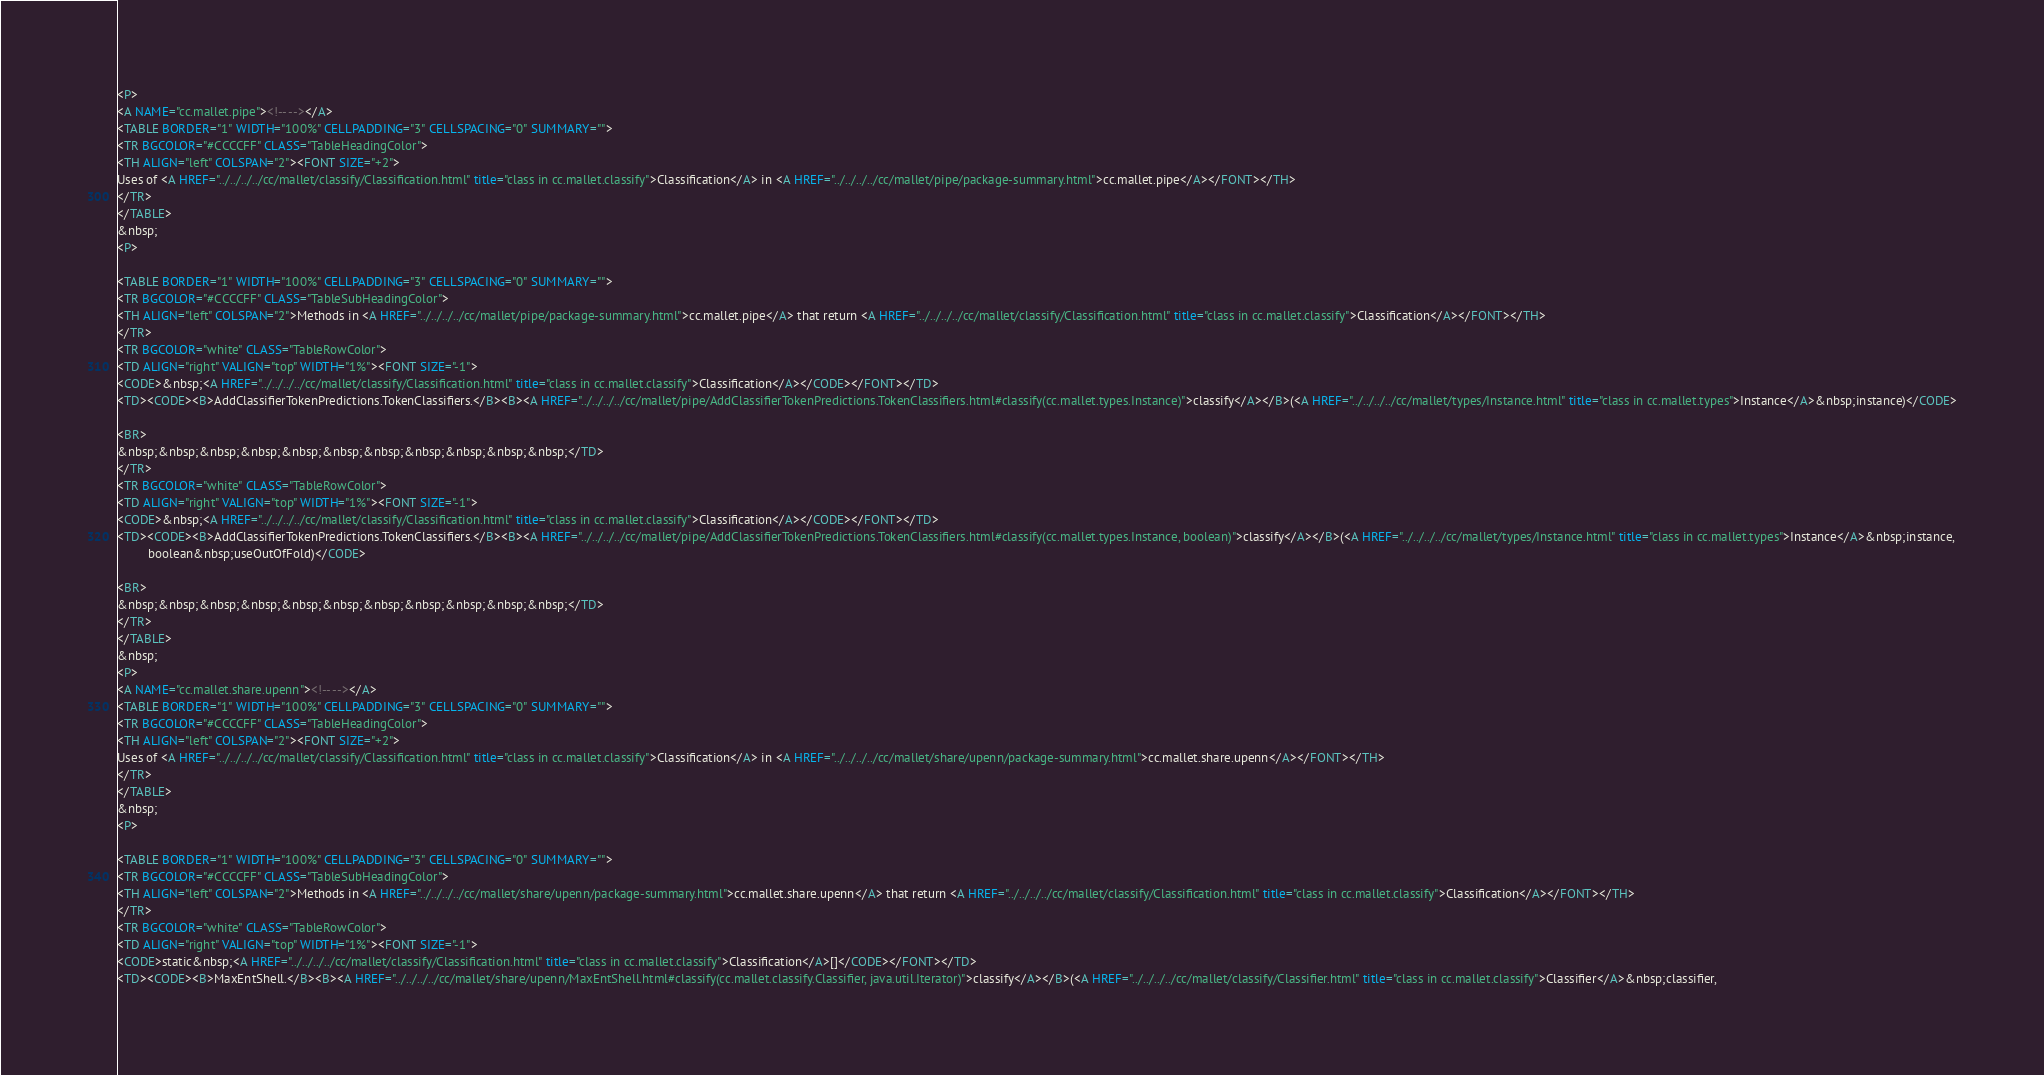<code> <loc_0><loc_0><loc_500><loc_500><_HTML_><P>
<A NAME="cc.mallet.pipe"><!-- --></A>
<TABLE BORDER="1" WIDTH="100%" CELLPADDING="3" CELLSPACING="0" SUMMARY="">
<TR BGCOLOR="#CCCCFF" CLASS="TableHeadingColor">
<TH ALIGN="left" COLSPAN="2"><FONT SIZE="+2">
Uses of <A HREF="../../../../cc/mallet/classify/Classification.html" title="class in cc.mallet.classify">Classification</A> in <A HREF="../../../../cc/mallet/pipe/package-summary.html">cc.mallet.pipe</A></FONT></TH>
</TR>
</TABLE>
&nbsp;
<P>

<TABLE BORDER="1" WIDTH="100%" CELLPADDING="3" CELLSPACING="0" SUMMARY="">
<TR BGCOLOR="#CCCCFF" CLASS="TableSubHeadingColor">
<TH ALIGN="left" COLSPAN="2">Methods in <A HREF="../../../../cc/mallet/pipe/package-summary.html">cc.mallet.pipe</A> that return <A HREF="../../../../cc/mallet/classify/Classification.html" title="class in cc.mallet.classify">Classification</A></FONT></TH>
</TR>
<TR BGCOLOR="white" CLASS="TableRowColor">
<TD ALIGN="right" VALIGN="top" WIDTH="1%"><FONT SIZE="-1">
<CODE>&nbsp;<A HREF="../../../../cc/mallet/classify/Classification.html" title="class in cc.mallet.classify">Classification</A></CODE></FONT></TD>
<TD><CODE><B>AddClassifierTokenPredictions.TokenClassifiers.</B><B><A HREF="../../../../cc/mallet/pipe/AddClassifierTokenPredictions.TokenClassifiers.html#classify(cc.mallet.types.Instance)">classify</A></B>(<A HREF="../../../../cc/mallet/types/Instance.html" title="class in cc.mallet.types">Instance</A>&nbsp;instance)</CODE>

<BR>
&nbsp;&nbsp;&nbsp;&nbsp;&nbsp;&nbsp;&nbsp;&nbsp;&nbsp;&nbsp;&nbsp;</TD>
</TR>
<TR BGCOLOR="white" CLASS="TableRowColor">
<TD ALIGN="right" VALIGN="top" WIDTH="1%"><FONT SIZE="-1">
<CODE>&nbsp;<A HREF="../../../../cc/mallet/classify/Classification.html" title="class in cc.mallet.classify">Classification</A></CODE></FONT></TD>
<TD><CODE><B>AddClassifierTokenPredictions.TokenClassifiers.</B><B><A HREF="../../../../cc/mallet/pipe/AddClassifierTokenPredictions.TokenClassifiers.html#classify(cc.mallet.types.Instance, boolean)">classify</A></B>(<A HREF="../../../../cc/mallet/types/Instance.html" title="class in cc.mallet.types">Instance</A>&nbsp;instance,
         boolean&nbsp;useOutOfFold)</CODE>

<BR>
&nbsp;&nbsp;&nbsp;&nbsp;&nbsp;&nbsp;&nbsp;&nbsp;&nbsp;&nbsp;&nbsp;</TD>
</TR>
</TABLE>
&nbsp;
<P>
<A NAME="cc.mallet.share.upenn"><!-- --></A>
<TABLE BORDER="1" WIDTH="100%" CELLPADDING="3" CELLSPACING="0" SUMMARY="">
<TR BGCOLOR="#CCCCFF" CLASS="TableHeadingColor">
<TH ALIGN="left" COLSPAN="2"><FONT SIZE="+2">
Uses of <A HREF="../../../../cc/mallet/classify/Classification.html" title="class in cc.mallet.classify">Classification</A> in <A HREF="../../../../cc/mallet/share/upenn/package-summary.html">cc.mallet.share.upenn</A></FONT></TH>
</TR>
</TABLE>
&nbsp;
<P>

<TABLE BORDER="1" WIDTH="100%" CELLPADDING="3" CELLSPACING="0" SUMMARY="">
<TR BGCOLOR="#CCCCFF" CLASS="TableSubHeadingColor">
<TH ALIGN="left" COLSPAN="2">Methods in <A HREF="../../../../cc/mallet/share/upenn/package-summary.html">cc.mallet.share.upenn</A> that return <A HREF="../../../../cc/mallet/classify/Classification.html" title="class in cc.mallet.classify">Classification</A></FONT></TH>
</TR>
<TR BGCOLOR="white" CLASS="TableRowColor">
<TD ALIGN="right" VALIGN="top" WIDTH="1%"><FONT SIZE="-1">
<CODE>static&nbsp;<A HREF="../../../../cc/mallet/classify/Classification.html" title="class in cc.mallet.classify">Classification</A>[]</CODE></FONT></TD>
<TD><CODE><B>MaxEntShell.</B><B><A HREF="../../../../cc/mallet/share/upenn/MaxEntShell.html#classify(cc.mallet.classify.Classifier, java.util.Iterator)">classify</A></B>(<A HREF="../../../../cc/mallet/classify/Classifier.html" title="class in cc.mallet.classify">Classifier</A>&nbsp;classifier,</code> 